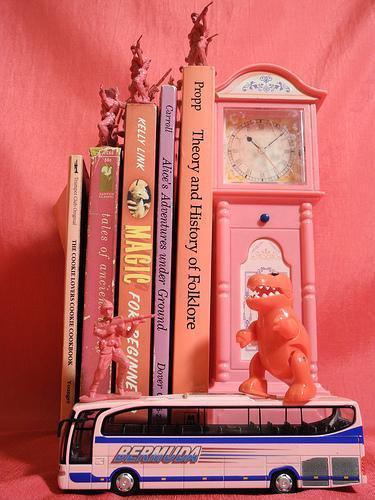How many buses are in the picture?
Give a very brief answer. 1. How many humans are in the picture?
Give a very brief answer. 0. 